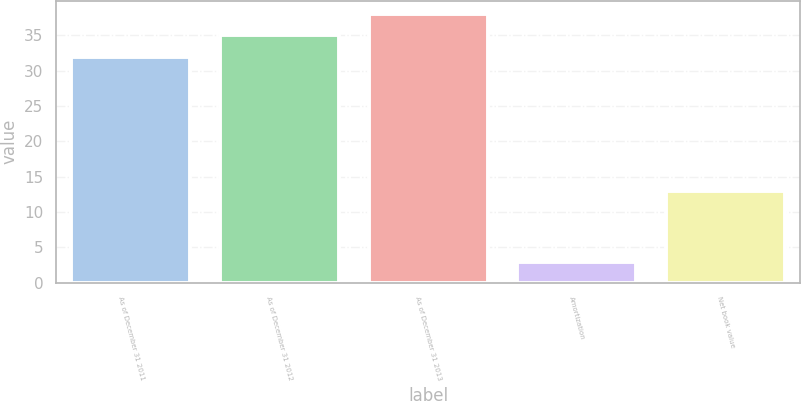<chart> <loc_0><loc_0><loc_500><loc_500><bar_chart><fcel>As of December 31 2011<fcel>As of December 31 2012<fcel>As of December 31 2013<fcel>Amortization<fcel>Net book value<nl><fcel>32<fcel>35<fcel>38<fcel>3<fcel>13<nl></chart> 